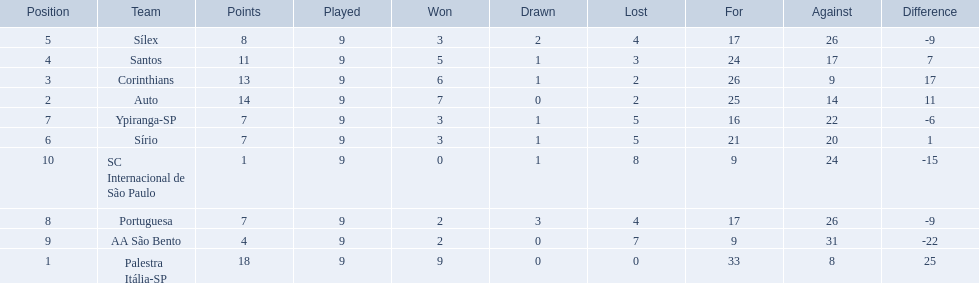How many teams played football in brazil during the year 1926? Palestra Itália-SP, Auto, Corinthians, Santos, Sílex, Sírio, Ypiranga-SP, Portuguesa, AA São Bento, SC Internacional de São Paulo. What was the highest number of games won during the 1926 season? 9. Which team was in the top spot with 9 wins for the 1926 season? Palestra Itália-SP. 